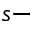<formula> <loc_0><loc_0><loc_500><loc_500>s -</formula> 